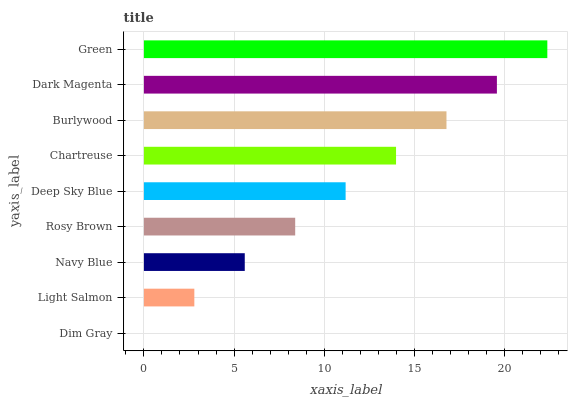Is Dim Gray the minimum?
Answer yes or no. Yes. Is Green the maximum?
Answer yes or no. Yes. Is Light Salmon the minimum?
Answer yes or no. No. Is Light Salmon the maximum?
Answer yes or no. No. Is Light Salmon greater than Dim Gray?
Answer yes or no. Yes. Is Dim Gray less than Light Salmon?
Answer yes or no. Yes. Is Dim Gray greater than Light Salmon?
Answer yes or no. No. Is Light Salmon less than Dim Gray?
Answer yes or no. No. Is Deep Sky Blue the high median?
Answer yes or no. Yes. Is Deep Sky Blue the low median?
Answer yes or no. Yes. Is Dim Gray the high median?
Answer yes or no. No. Is Chartreuse the low median?
Answer yes or no. No. 